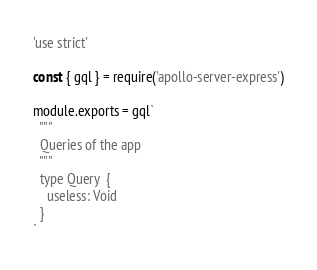<code> <loc_0><loc_0><loc_500><loc_500><_JavaScript_>'use strict'

const { gql } = require('apollo-server-express')

module.exports = gql`
  """
  Queries of the app
  """
  type Query  {
    useless: Void
  }
`
</code> 